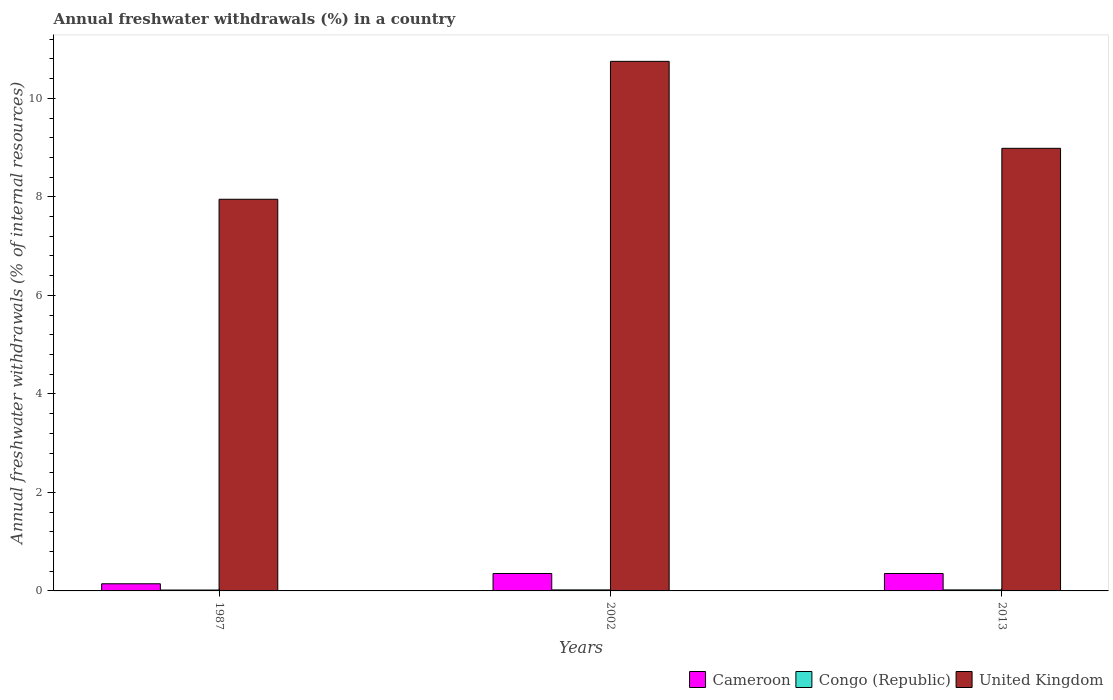How many different coloured bars are there?
Keep it short and to the point. 3. How many groups of bars are there?
Your response must be concise. 3. Are the number of bars per tick equal to the number of legend labels?
Your answer should be compact. Yes. How many bars are there on the 1st tick from the right?
Provide a succinct answer. 3. In how many cases, is the number of bars for a given year not equal to the number of legend labels?
Give a very brief answer. 0. What is the percentage of annual freshwater withdrawals in Congo (Republic) in 2002?
Provide a succinct answer. 0.02. Across all years, what is the maximum percentage of annual freshwater withdrawals in Cameroon?
Your answer should be compact. 0.35. Across all years, what is the minimum percentage of annual freshwater withdrawals in Congo (Republic)?
Offer a terse response. 0.02. In which year was the percentage of annual freshwater withdrawals in United Kingdom maximum?
Offer a very short reply. 2002. What is the total percentage of annual freshwater withdrawals in Congo (Republic) in the graph?
Offer a very short reply. 0.06. What is the difference between the percentage of annual freshwater withdrawals in United Kingdom in 2002 and the percentage of annual freshwater withdrawals in Congo (Republic) in 2013?
Provide a succinct answer. 10.73. What is the average percentage of annual freshwater withdrawals in Cameroon per year?
Provide a succinct answer. 0.28. In the year 2002, what is the difference between the percentage of annual freshwater withdrawals in Congo (Republic) and percentage of annual freshwater withdrawals in Cameroon?
Ensure brevity in your answer.  -0.33. What is the ratio of the percentage of annual freshwater withdrawals in United Kingdom in 1987 to that in 2013?
Your response must be concise. 0.88. Is the percentage of annual freshwater withdrawals in Congo (Republic) in 2002 less than that in 2013?
Provide a succinct answer. No. Is the difference between the percentage of annual freshwater withdrawals in Congo (Republic) in 1987 and 2013 greater than the difference between the percentage of annual freshwater withdrawals in Cameroon in 1987 and 2013?
Make the answer very short. Yes. What is the difference between the highest and the second highest percentage of annual freshwater withdrawals in United Kingdom?
Offer a terse response. 1.77. What is the difference between the highest and the lowest percentage of annual freshwater withdrawals in Congo (Republic)?
Give a very brief answer. 0. In how many years, is the percentage of annual freshwater withdrawals in Cameroon greater than the average percentage of annual freshwater withdrawals in Cameroon taken over all years?
Give a very brief answer. 2. What does the 1st bar from the left in 1987 represents?
Offer a very short reply. Cameroon. What does the 1st bar from the right in 2002 represents?
Ensure brevity in your answer.  United Kingdom. Are all the bars in the graph horizontal?
Provide a short and direct response. No. What is the difference between two consecutive major ticks on the Y-axis?
Make the answer very short. 2. Does the graph contain any zero values?
Ensure brevity in your answer.  No. What is the title of the graph?
Give a very brief answer. Annual freshwater withdrawals (%) in a country. Does "Mozambique" appear as one of the legend labels in the graph?
Your answer should be compact. No. What is the label or title of the Y-axis?
Offer a terse response. Annual freshwater withdrawals (% of internal resources). What is the Annual freshwater withdrawals (% of internal resources) of Cameroon in 1987?
Your answer should be very brief. 0.15. What is the Annual freshwater withdrawals (% of internal resources) in Congo (Republic) in 1987?
Make the answer very short. 0.02. What is the Annual freshwater withdrawals (% of internal resources) of United Kingdom in 1987?
Provide a succinct answer. 7.95. What is the Annual freshwater withdrawals (% of internal resources) of Cameroon in 2002?
Your answer should be very brief. 0.35. What is the Annual freshwater withdrawals (% of internal resources) of Congo (Republic) in 2002?
Offer a very short reply. 0.02. What is the Annual freshwater withdrawals (% of internal resources) in United Kingdom in 2002?
Make the answer very short. 10.75. What is the Annual freshwater withdrawals (% of internal resources) in Cameroon in 2013?
Provide a succinct answer. 0.35. What is the Annual freshwater withdrawals (% of internal resources) of Congo (Republic) in 2013?
Give a very brief answer. 0.02. What is the Annual freshwater withdrawals (% of internal resources) in United Kingdom in 2013?
Make the answer very short. 8.99. Across all years, what is the maximum Annual freshwater withdrawals (% of internal resources) of Cameroon?
Give a very brief answer. 0.35. Across all years, what is the maximum Annual freshwater withdrawals (% of internal resources) in Congo (Republic)?
Ensure brevity in your answer.  0.02. Across all years, what is the maximum Annual freshwater withdrawals (% of internal resources) in United Kingdom?
Provide a short and direct response. 10.75. Across all years, what is the minimum Annual freshwater withdrawals (% of internal resources) of Cameroon?
Give a very brief answer. 0.15. Across all years, what is the minimum Annual freshwater withdrawals (% of internal resources) of Congo (Republic)?
Offer a very short reply. 0.02. Across all years, what is the minimum Annual freshwater withdrawals (% of internal resources) in United Kingdom?
Your response must be concise. 7.95. What is the total Annual freshwater withdrawals (% of internal resources) of Cameroon in the graph?
Your response must be concise. 0.85. What is the total Annual freshwater withdrawals (% of internal resources) in Congo (Republic) in the graph?
Your answer should be compact. 0.06. What is the total Annual freshwater withdrawals (% of internal resources) of United Kingdom in the graph?
Your response must be concise. 27.69. What is the difference between the Annual freshwater withdrawals (% of internal resources) in Cameroon in 1987 and that in 2002?
Offer a very short reply. -0.21. What is the difference between the Annual freshwater withdrawals (% of internal resources) of Congo (Republic) in 1987 and that in 2002?
Keep it short and to the point. -0. What is the difference between the Annual freshwater withdrawals (% of internal resources) of Cameroon in 1987 and that in 2013?
Your answer should be compact. -0.21. What is the difference between the Annual freshwater withdrawals (% of internal resources) in Congo (Republic) in 1987 and that in 2013?
Make the answer very short. -0. What is the difference between the Annual freshwater withdrawals (% of internal resources) in United Kingdom in 1987 and that in 2013?
Ensure brevity in your answer.  -1.03. What is the difference between the Annual freshwater withdrawals (% of internal resources) in Cameroon in 2002 and that in 2013?
Offer a terse response. 0. What is the difference between the Annual freshwater withdrawals (% of internal resources) of Congo (Republic) in 2002 and that in 2013?
Give a very brief answer. 0. What is the difference between the Annual freshwater withdrawals (% of internal resources) of United Kingdom in 2002 and that in 2013?
Your answer should be very brief. 1.77. What is the difference between the Annual freshwater withdrawals (% of internal resources) in Cameroon in 1987 and the Annual freshwater withdrawals (% of internal resources) in Congo (Republic) in 2002?
Give a very brief answer. 0.12. What is the difference between the Annual freshwater withdrawals (% of internal resources) of Cameroon in 1987 and the Annual freshwater withdrawals (% of internal resources) of United Kingdom in 2002?
Give a very brief answer. -10.61. What is the difference between the Annual freshwater withdrawals (% of internal resources) of Congo (Republic) in 1987 and the Annual freshwater withdrawals (% of internal resources) of United Kingdom in 2002?
Give a very brief answer. -10.73. What is the difference between the Annual freshwater withdrawals (% of internal resources) in Cameroon in 1987 and the Annual freshwater withdrawals (% of internal resources) in Congo (Republic) in 2013?
Your response must be concise. 0.12. What is the difference between the Annual freshwater withdrawals (% of internal resources) in Cameroon in 1987 and the Annual freshwater withdrawals (% of internal resources) in United Kingdom in 2013?
Your response must be concise. -8.84. What is the difference between the Annual freshwater withdrawals (% of internal resources) in Congo (Republic) in 1987 and the Annual freshwater withdrawals (% of internal resources) in United Kingdom in 2013?
Your answer should be compact. -8.97. What is the difference between the Annual freshwater withdrawals (% of internal resources) in Cameroon in 2002 and the Annual freshwater withdrawals (% of internal resources) in United Kingdom in 2013?
Offer a very short reply. -8.63. What is the difference between the Annual freshwater withdrawals (% of internal resources) in Congo (Republic) in 2002 and the Annual freshwater withdrawals (% of internal resources) in United Kingdom in 2013?
Your answer should be compact. -8.97. What is the average Annual freshwater withdrawals (% of internal resources) in Cameroon per year?
Your response must be concise. 0.28. What is the average Annual freshwater withdrawals (% of internal resources) in Congo (Republic) per year?
Your response must be concise. 0.02. What is the average Annual freshwater withdrawals (% of internal resources) of United Kingdom per year?
Your answer should be compact. 9.23. In the year 1987, what is the difference between the Annual freshwater withdrawals (% of internal resources) in Cameroon and Annual freshwater withdrawals (% of internal resources) in Congo (Republic)?
Give a very brief answer. 0.13. In the year 1987, what is the difference between the Annual freshwater withdrawals (% of internal resources) in Cameroon and Annual freshwater withdrawals (% of internal resources) in United Kingdom?
Make the answer very short. -7.81. In the year 1987, what is the difference between the Annual freshwater withdrawals (% of internal resources) of Congo (Republic) and Annual freshwater withdrawals (% of internal resources) of United Kingdom?
Your response must be concise. -7.93. In the year 2002, what is the difference between the Annual freshwater withdrawals (% of internal resources) of Cameroon and Annual freshwater withdrawals (% of internal resources) of Congo (Republic)?
Give a very brief answer. 0.33. In the year 2002, what is the difference between the Annual freshwater withdrawals (% of internal resources) in Cameroon and Annual freshwater withdrawals (% of internal resources) in United Kingdom?
Give a very brief answer. -10.4. In the year 2002, what is the difference between the Annual freshwater withdrawals (% of internal resources) in Congo (Republic) and Annual freshwater withdrawals (% of internal resources) in United Kingdom?
Provide a short and direct response. -10.73. In the year 2013, what is the difference between the Annual freshwater withdrawals (% of internal resources) of Cameroon and Annual freshwater withdrawals (% of internal resources) of Congo (Republic)?
Ensure brevity in your answer.  0.33. In the year 2013, what is the difference between the Annual freshwater withdrawals (% of internal resources) in Cameroon and Annual freshwater withdrawals (% of internal resources) in United Kingdom?
Keep it short and to the point. -8.63. In the year 2013, what is the difference between the Annual freshwater withdrawals (% of internal resources) in Congo (Republic) and Annual freshwater withdrawals (% of internal resources) in United Kingdom?
Provide a succinct answer. -8.97. What is the ratio of the Annual freshwater withdrawals (% of internal resources) of Cameroon in 1987 to that in 2002?
Provide a short and direct response. 0.41. What is the ratio of the Annual freshwater withdrawals (% of internal resources) of Congo (Republic) in 1987 to that in 2002?
Provide a succinct answer. 0.87. What is the ratio of the Annual freshwater withdrawals (% of internal resources) of United Kingdom in 1987 to that in 2002?
Offer a very short reply. 0.74. What is the ratio of the Annual freshwater withdrawals (% of internal resources) of Cameroon in 1987 to that in 2013?
Offer a terse response. 0.41. What is the ratio of the Annual freshwater withdrawals (% of internal resources) of Congo (Republic) in 1987 to that in 2013?
Ensure brevity in your answer.  0.87. What is the ratio of the Annual freshwater withdrawals (% of internal resources) in United Kingdom in 1987 to that in 2013?
Your answer should be compact. 0.88. What is the ratio of the Annual freshwater withdrawals (% of internal resources) of Cameroon in 2002 to that in 2013?
Your response must be concise. 1. What is the ratio of the Annual freshwater withdrawals (% of internal resources) of Congo (Republic) in 2002 to that in 2013?
Your response must be concise. 1. What is the ratio of the Annual freshwater withdrawals (% of internal resources) of United Kingdom in 2002 to that in 2013?
Your answer should be very brief. 1.2. What is the difference between the highest and the second highest Annual freshwater withdrawals (% of internal resources) in Congo (Republic)?
Offer a terse response. 0. What is the difference between the highest and the second highest Annual freshwater withdrawals (% of internal resources) in United Kingdom?
Make the answer very short. 1.77. What is the difference between the highest and the lowest Annual freshwater withdrawals (% of internal resources) in Cameroon?
Offer a very short reply. 0.21. What is the difference between the highest and the lowest Annual freshwater withdrawals (% of internal resources) in Congo (Republic)?
Give a very brief answer. 0. What is the difference between the highest and the lowest Annual freshwater withdrawals (% of internal resources) in United Kingdom?
Your response must be concise. 2.8. 